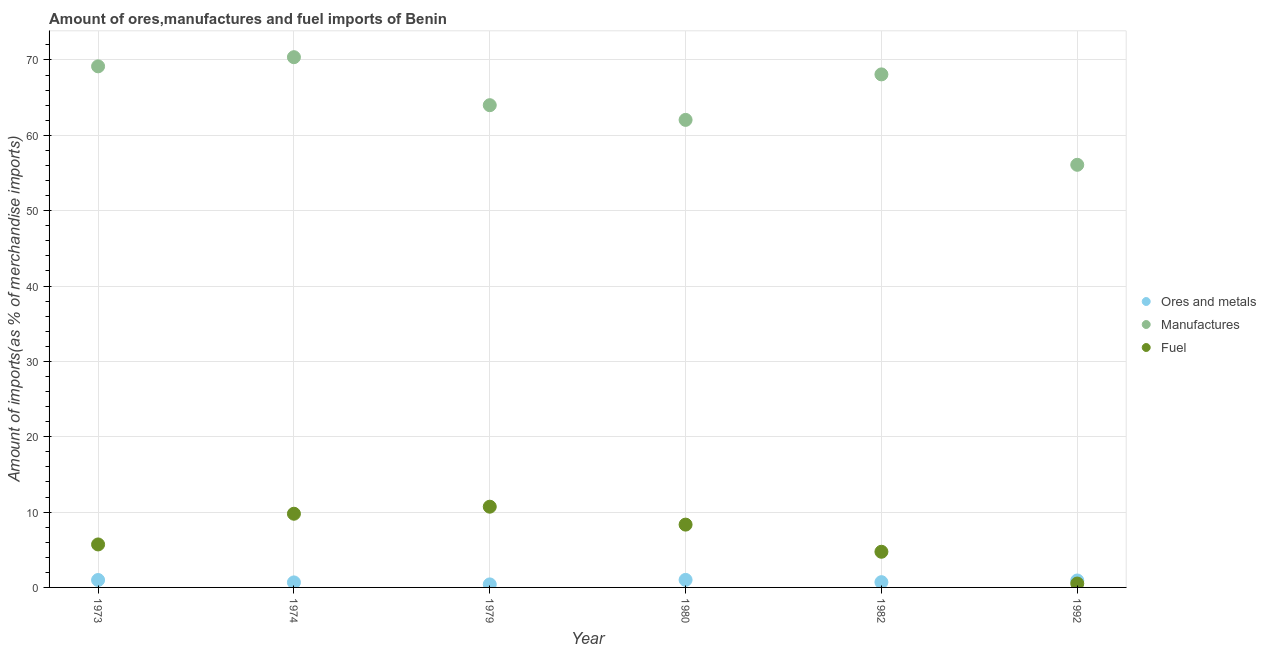What is the percentage of fuel imports in 1982?
Make the answer very short. 4.73. Across all years, what is the maximum percentage of fuel imports?
Ensure brevity in your answer.  10.71. Across all years, what is the minimum percentage of manufactures imports?
Your answer should be very brief. 56.08. In which year was the percentage of manufactures imports minimum?
Your answer should be very brief. 1992. What is the total percentage of ores and metals imports in the graph?
Your answer should be very brief. 4.67. What is the difference between the percentage of ores and metals imports in 1982 and that in 1992?
Keep it short and to the point. -0.22. What is the difference between the percentage of fuel imports in 1973 and the percentage of ores and metals imports in 1992?
Your answer should be compact. 4.78. What is the average percentage of manufactures imports per year?
Your answer should be compact. 64.95. In the year 1992, what is the difference between the percentage of fuel imports and percentage of ores and metals imports?
Give a very brief answer. -0.41. In how many years, is the percentage of fuel imports greater than 18 %?
Ensure brevity in your answer.  0. What is the ratio of the percentage of manufactures imports in 1974 to that in 1979?
Offer a terse response. 1.1. Is the difference between the percentage of ores and metals imports in 1974 and 1982 greater than the difference between the percentage of manufactures imports in 1974 and 1982?
Your answer should be compact. No. What is the difference between the highest and the second highest percentage of ores and metals imports?
Provide a succinct answer. 0.02. What is the difference between the highest and the lowest percentage of fuel imports?
Provide a short and direct response. 10.2. Does the percentage of fuel imports monotonically increase over the years?
Keep it short and to the point. No. Is the percentage of fuel imports strictly less than the percentage of ores and metals imports over the years?
Keep it short and to the point. No. How many dotlines are there?
Your answer should be compact. 3. What is the difference between two consecutive major ticks on the Y-axis?
Give a very brief answer. 10. Are the values on the major ticks of Y-axis written in scientific E-notation?
Your answer should be compact. No. Does the graph contain any zero values?
Provide a succinct answer. No. Does the graph contain grids?
Make the answer very short. Yes. How are the legend labels stacked?
Your response must be concise. Vertical. What is the title of the graph?
Make the answer very short. Amount of ores,manufactures and fuel imports of Benin. Does "Manufactures" appear as one of the legend labels in the graph?
Give a very brief answer. Yes. What is the label or title of the Y-axis?
Your answer should be very brief. Amount of imports(as % of merchandise imports). What is the Amount of imports(as % of merchandise imports) of Ores and metals in 1973?
Your answer should be compact. 0.98. What is the Amount of imports(as % of merchandise imports) of Manufactures in 1973?
Ensure brevity in your answer.  69.15. What is the Amount of imports(as % of merchandise imports) of Fuel in 1973?
Give a very brief answer. 5.7. What is the Amount of imports(as % of merchandise imports) in Ores and metals in 1974?
Ensure brevity in your answer.  0.67. What is the Amount of imports(as % of merchandise imports) of Manufactures in 1974?
Your response must be concise. 70.37. What is the Amount of imports(as % of merchandise imports) in Fuel in 1974?
Keep it short and to the point. 9.78. What is the Amount of imports(as % of merchandise imports) in Ores and metals in 1979?
Your answer should be very brief. 0.4. What is the Amount of imports(as % of merchandise imports) of Manufactures in 1979?
Your answer should be compact. 64. What is the Amount of imports(as % of merchandise imports) in Fuel in 1979?
Keep it short and to the point. 10.71. What is the Amount of imports(as % of merchandise imports) of Ores and metals in 1980?
Give a very brief answer. 1. What is the Amount of imports(as % of merchandise imports) in Manufactures in 1980?
Ensure brevity in your answer.  62.05. What is the Amount of imports(as % of merchandise imports) of Fuel in 1980?
Provide a short and direct response. 8.34. What is the Amount of imports(as % of merchandise imports) of Ores and metals in 1982?
Offer a terse response. 0.7. What is the Amount of imports(as % of merchandise imports) of Manufactures in 1982?
Make the answer very short. 68.08. What is the Amount of imports(as % of merchandise imports) of Fuel in 1982?
Your response must be concise. 4.73. What is the Amount of imports(as % of merchandise imports) of Ores and metals in 1992?
Ensure brevity in your answer.  0.92. What is the Amount of imports(as % of merchandise imports) in Manufactures in 1992?
Your answer should be compact. 56.08. What is the Amount of imports(as % of merchandise imports) of Fuel in 1992?
Give a very brief answer. 0.52. Across all years, what is the maximum Amount of imports(as % of merchandise imports) of Ores and metals?
Make the answer very short. 1. Across all years, what is the maximum Amount of imports(as % of merchandise imports) in Manufactures?
Keep it short and to the point. 70.37. Across all years, what is the maximum Amount of imports(as % of merchandise imports) in Fuel?
Ensure brevity in your answer.  10.71. Across all years, what is the minimum Amount of imports(as % of merchandise imports) of Ores and metals?
Your answer should be very brief. 0.4. Across all years, what is the minimum Amount of imports(as % of merchandise imports) in Manufactures?
Ensure brevity in your answer.  56.08. Across all years, what is the minimum Amount of imports(as % of merchandise imports) of Fuel?
Offer a terse response. 0.52. What is the total Amount of imports(as % of merchandise imports) in Ores and metals in the graph?
Keep it short and to the point. 4.67. What is the total Amount of imports(as % of merchandise imports) of Manufactures in the graph?
Provide a succinct answer. 389.73. What is the total Amount of imports(as % of merchandise imports) of Fuel in the graph?
Your response must be concise. 39.78. What is the difference between the Amount of imports(as % of merchandise imports) in Ores and metals in 1973 and that in 1974?
Your answer should be compact. 0.32. What is the difference between the Amount of imports(as % of merchandise imports) of Manufactures in 1973 and that in 1974?
Offer a terse response. -1.21. What is the difference between the Amount of imports(as % of merchandise imports) of Fuel in 1973 and that in 1974?
Offer a terse response. -4.07. What is the difference between the Amount of imports(as % of merchandise imports) of Ores and metals in 1973 and that in 1979?
Ensure brevity in your answer.  0.58. What is the difference between the Amount of imports(as % of merchandise imports) of Manufactures in 1973 and that in 1979?
Ensure brevity in your answer.  5.16. What is the difference between the Amount of imports(as % of merchandise imports) in Fuel in 1973 and that in 1979?
Ensure brevity in your answer.  -5.01. What is the difference between the Amount of imports(as % of merchandise imports) of Ores and metals in 1973 and that in 1980?
Your answer should be very brief. -0.02. What is the difference between the Amount of imports(as % of merchandise imports) in Manufactures in 1973 and that in 1980?
Your answer should be compact. 7.11. What is the difference between the Amount of imports(as % of merchandise imports) in Fuel in 1973 and that in 1980?
Keep it short and to the point. -2.63. What is the difference between the Amount of imports(as % of merchandise imports) in Ores and metals in 1973 and that in 1982?
Ensure brevity in your answer.  0.28. What is the difference between the Amount of imports(as % of merchandise imports) in Manufactures in 1973 and that in 1982?
Your response must be concise. 1.07. What is the difference between the Amount of imports(as % of merchandise imports) of Fuel in 1973 and that in 1982?
Provide a succinct answer. 0.97. What is the difference between the Amount of imports(as % of merchandise imports) in Ores and metals in 1973 and that in 1992?
Keep it short and to the point. 0.06. What is the difference between the Amount of imports(as % of merchandise imports) of Manufactures in 1973 and that in 1992?
Make the answer very short. 13.07. What is the difference between the Amount of imports(as % of merchandise imports) in Fuel in 1973 and that in 1992?
Provide a short and direct response. 5.19. What is the difference between the Amount of imports(as % of merchandise imports) of Ores and metals in 1974 and that in 1979?
Your answer should be very brief. 0.27. What is the difference between the Amount of imports(as % of merchandise imports) in Manufactures in 1974 and that in 1979?
Offer a very short reply. 6.37. What is the difference between the Amount of imports(as % of merchandise imports) in Fuel in 1974 and that in 1979?
Offer a terse response. -0.93. What is the difference between the Amount of imports(as % of merchandise imports) of Ores and metals in 1974 and that in 1980?
Offer a terse response. -0.33. What is the difference between the Amount of imports(as % of merchandise imports) in Manufactures in 1974 and that in 1980?
Offer a terse response. 8.32. What is the difference between the Amount of imports(as % of merchandise imports) of Fuel in 1974 and that in 1980?
Keep it short and to the point. 1.44. What is the difference between the Amount of imports(as % of merchandise imports) in Ores and metals in 1974 and that in 1982?
Provide a short and direct response. -0.03. What is the difference between the Amount of imports(as % of merchandise imports) in Manufactures in 1974 and that in 1982?
Provide a short and direct response. 2.28. What is the difference between the Amount of imports(as % of merchandise imports) in Fuel in 1974 and that in 1982?
Make the answer very short. 5.05. What is the difference between the Amount of imports(as % of merchandise imports) in Ores and metals in 1974 and that in 1992?
Your answer should be very brief. -0.25. What is the difference between the Amount of imports(as % of merchandise imports) in Manufactures in 1974 and that in 1992?
Provide a succinct answer. 14.28. What is the difference between the Amount of imports(as % of merchandise imports) in Fuel in 1974 and that in 1992?
Ensure brevity in your answer.  9.26. What is the difference between the Amount of imports(as % of merchandise imports) in Ores and metals in 1979 and that in 1980?
Offer a terse response. -0.6. What is the difference between the Amount of imports(as % of merchandise imports) of Manufactures in 1979 and that in 1980?
Provide a short and direct response. 1.95. What is the difference between the Amount of imports(as % of merchandise imports) in Fuel in 1979 and that in 1980?
Your answer should be very brief. 2.38. What is the difference between the Amount of imports(as % of merchandise imports) of Ores and metals in 1979 and that in 1982?
Provide a succinct answer. -0.3. What is the difference between the Amount of imports(as % of merchandise imports) of Manufactures in 1979 and that in 1982?
Provide a succinct answer. -4.09. What is the difference between the Amount of imports(as % of merchandise imports) of Fuel in 1979 and that in 1982?
Ensure brevity in your answer.  5.98. What is the difference between the Amount of imports(as % of merchandise imports) in Ores and metals in 1979 and that in 1992?
Keep it short and to the point. -0.52. What is the difference between the Amount of imports(as % of merchandise imports) of Manufactures in 1979 and that in 1992?
Offer a very short reply. 7.91. What is the difference between the Amount of imports(as % of merchandise imports) in Fuel in 1979 and that in 1992?
Your answer should be very brief. 10.2. What is the difference between the Amount of imports(as % of merchandise imports) of Ores and metals in 1980 and that in 1982?
Your answer should be very brief. 0.3. What is the difference between the Amount of imports(as % of merchandise imports) of Manufactures in 1980 and that in 1982?
Provide a succinct answer. -6.04. What is the difference between the Amount of imports(as % of merchandise imports) in Fuel in 1980 and that in 1982?
Keep it short and to the point. 3.6. What is the difference between the Amount of imports(as % of merchandise imports) of Ores and metals in 1980 and that in 1992?
Keep it short and to the point. 0.08. What is the difference between the Amount of imports(as % of merchandise imports) of Manufactures in 1980 and that in 1992?
Provide a succinct answer. 5.96. What is the difference between the Amount of imports(as % of merchandise imports) in Fuel in 1980 and that in 1992?
Ensure brevity in your answer.  7.82. What is the difference between the Amount of imports(as % of merchandise imports) in Ores and metals in 1982 and that in 1992?
Offer a very short reply. -0.22. What is the difference between the Amount of imports(as % of merchandise imports) of Manufactures in 1982 and that in 1992?
Offer a terse response. 12. What is the difference between the Amount of imports(as % of merchandise imports) in Fuel in 1982 and that in 1992?
Provide a succinct answer. 4.22. What is the difference between the Amount of imports(as % of merchandise imports) of Ores and metals in 1973 and the Amount of imports(as % of merchandise imports) of Manufactures in 1974?
Make the answer very short. -69.38. What is the difference between the Amount of imports(as % of merchandise imports) in Ores and metals in 1973 and the Amount of imports(as % of merchandise imports) in Fuel in 1974?
Keep it short and to the point. -8.8. What is the difference between the Amount of imports(as % of merchandise imports) of Manufactures in 1973 and the Amount of imports(as % of merchandise imports) of Fuel in 1974?
Provide a short and direct response. 59.37. What is the difference between the Amount of imports(as % of merchandise imports) in Ores and metals in 1973 and the Amount of imports(as % of merchandise imports) in Manufactures in 1979?
Provide a short and direct response. -63.01. What is the difference between the Amount of imports(as % of merchandise imports) of Ores and metals in 1973 and the Amount of imports(as % of merchandise imports) of Fuel in 1979?
Provide a short and direct response. -9.73. What is the difference between the Amount of imports(as % of merchandise imports) of Manufactures in 1973 and the Amount of imports(as % of merchandise imports) of Fuel in 1979?
Offer a very short reply. 58.44. What is the difference between the Amount of imports(as % of merchandise imports) in Ores and metals in 1973 and the Amount of imports(as % of merchandise imports) in Manufactures in 1980?
Provide a short and direct response. -61.06. What is the difference between the Amount of imports(as % of merchandise imports) in Ores and metals in 1973 and the Amount of imports(as % of merchandise imports) in Fuel in 1980?
Your answer should be compact. -7.35. What is the difference between the Amount of imports(as % of merchandise imports) in Manufactures in 1973 and the Amount of imports(as % of merchandise imports) in Fuel in 1980?
Provide a short and direct response. 60.82. What is the difference between the Amount of imports(as % of merchandise imports) of Ores and metals in 1973 and the Amount of imports(as % of merchandise imports) of Manufactures in 1982?
Make the answer very short. -67.1. What is the difference between the Amount of imports(as % of merchandise imports) in Ores and metals in 1973 and the Amount of imports(as % of merchandise imports) in Fuel in 1982?
Offer a very short reply. -3.75. What is the difference between the Amount of imports(as % of merchandise imports) of Manufactures in 1973 and the Amount of imports(as % of merchandise imports) of Fuel in 1982?
Ensure brevity in your answer.  64.42. What is the difference between the Amount of imports(as % of merchandise imports) of Ores and metals in 1973 and the Amount of imports(as % of merchandise imports) of Manufactures in 1992?
Provide a succinct answer. -55.1. What is the difference between the Amount of imports(as % of merchandise imports) in Ores and metals in 1973 and the Amount of imports(as % of merchandise imports) in Fuel in 1992?
Provide a succinct answer. 0.47. What is the difference between the Amount of imports(as % of merchandise imports) in Manufactures in 1973 and the Amount of imports(as % of merchandise imports) in Fuel in 1992?
Your answer should be very brief. 68.64. What is the difference between the Amount of imports(as % of merchandise imports) of Ores and metals in 1974 and the Amount of imports(as % of merchandise imports) of Manufactures in 1979?
Your response must be concise. -63.33. What is the difference between the Amount of imports(as % of merchandise imports) of Ores and metals in 1974 and the Amount of imports(as % of merchandise imports) of Fuel in 1979?
Provide a short and direct response. -10.05. What is the difference between the Amount of imports(as % of merchandise imports) of Manufactures in 1974 and the Amount of imports(as % of merchandise imports) of Fuel in 1979?
Keep it short and to the point. 59.65. What is the difference between the Amount of imports(as % of merchandise imports) in Ores and metals in 1974 and the Amount of imports(as % of merchandise imports) in Manufactures in 1980?
Your response must be concise. -61.38. What is the difference between the Amount of imports(as % of merchandise imports) in Ores and metals in 1974 and the Amount of imports(as % of merchandise imports) in Fuel in 1980?
Offer a very short reply. -7.67. What is the difference between the Amount of imports(as % of merchandise imports) in Manufactures in 1974 and the Amount of imports(as % of merchandise imports) in Fuel in 1980?
Give a very brief answer. 62.03. What is the difference between the Amount of imports(as % of merchandise imports) of Ores and metals in 1974 and the Amount of imports(as % of merchandise imports) of Manufactures in 1982?
Your response must be concise. -67.42. What is the difference between the Amount of imports(as % of merchandise imports) of Ores and metals in 1974 and the Amount of imports(as % of merchandise imports) of Fuel in 1982?
Provide a short and direct response. -4.07. What is the difference between the Amount of imports(as % of merchandise imports) in Manufactures in 1974 and the Amount of imports(as % of merchandise imports) in Fuel in 1982?
Your answer should be very brief. 65.63. What is the difference between the Amount of imports(as % of merchandise imports) of Ores and metals in 1974 and the Amount of imports(as % of merchandise imports) of Manufactures in 1992?
Provide a short and direct response. -55.42. What is the difference between the Amount of imports(as % of merchandise imports) in Ores and metals in 1974 and the Amount of imports(as % of merchandise imports) in Fuel in 1992?
Your response must be concise. 0.15. What is the difference between the Amount of imports(as % of merchandise imports) in Manufactures in 1974 and the Amount of imports(as % of merchandise imports) in Fuel in 1992?
Offer a terse response. 69.85. What is the difference between the Amount of imports(as % of merchandise imports) of Ores and metals in 1979 and the Amount of imports(as % of merchandise imports) of Manufactures in 1980?
Give a very brief answer. -61.65. What is the difference between the Amount of imports(as % of merchandise imports) in Ores and metals in 1979 and the Amount of imports(as % of merchandise imports) in Fuel in 1980?
Your response must be concise. -7.94. What is the difference between the Amount of imports(as % of merchandise imports) of Manufactures in 1979 and the Amount of imports(as % of merchandise imports) of Fuel in 1980?
Your answer should be compact. 55.66. What is the difference between the Amount of imports(as % of merchandise imports) in Ores and metals in 1979 and the Amount of imports(as % of merchandise imports) in Manufactures in 1982?
Make the answer very short. -67.68. What is the difference between the Amount of imports(as % of merchandise imports) of Ores and metals in 1979 and the Amount of imports(as % of merchandise imports) of Fuel in 1982?
Offer a very short reply. -4.33. What is the difference between the Amount of imports(as % of merchandise imports) in Manufactures in 1979 and the Amount of imports(as % of merchandise imports) in Fuel in 1982?
Give a very brief answer. 59.26. What is the difference between the Amount of imports(as % of merchandise imports) of Ores and metals in 1979 and the Amount of imports(as % of merchandise imports) of Manufactures in 1992?
Keep it short and to the point. -55.68. What is the difference between the Amount of imports(as % of merchandise imports) of Ores and metals in 1979 and the Amount of imports(as % of merchandise imports) of Fuel in 1992?
Your answer should be compact. -0.11. What is the difference between the Amount of imports(as % of merchandise imports) in Manufactures in 1979 and the Amount of imports(as % of merchandise imports) in Fuel in 1992?
Make the answer very short. 63.48. What is the difference between the Amount of imports(as % of merchandise imports) in Ores and metals in 1980 and the Amount of imports(as % of merchandise imports) in Manufactures in 1982?
Your response must be concise. -67.08. What is the difference between the Amount of imports(as % of merchandise imports) in Ores and metals in 1980 and the Amount of imports(as % of merchandise imports) in Fuel in 1982?
Ensure brevity in your answer.  -3.73. What is the difference between the Amount of imports(as % of merchandise imports) of Manufactures in 1980 and the Amount of imports(as % of merchandise imports) of Fuel in 1982?
Ensure brevity in your answer.  57.31. What is the difference between the Amount of imports(as % of merchandise imports) of Ores and metals in 1980 and the Amount of imports(as % of merchandise imports) of Manufactures in 1992?
Offer a terse response. -55.09. What is the difference between the Amount of imports(as % of merchandise imports) of Ores and metals in 1980 and the Amount of imports(as % of merchandise imports) of Fuel in 1992?
Your answer should be compact. 0.48. What is the difference between the Amount of imports(as % of merchandise imports) of Manufactures in 1980 and the Amount of imports(as % of merchandise imports) of Fuel in 1992?
Your answer should be very brief. 61.53. What is the difference between the Amount of imports(as % of merchandise imports) of Ores and metals in 1982 and the Amount of imports(as % of merchandise imports) of Manufactures in 1992?
Make the answer very short. -55.39. What is the difference between the Amount of imports(as % of merchandise imports) in Ores and metals in 1982 and the Amount of imports(as % of merchandise imports) in Fuel in 1992?
Keep it short and to the point. 0.18. What is the difference between the Amount of imports(as % of merchandise imports) of Manufactures in 1982 and the Amount of imports(as % of merchandise imports) of Fuel in 1992?
Offer a terse response. 67.57. What is the average Amount of imports(as % of merchandise imports) of Ores and metals per year?
Give a very brief answer. 0.78. What is the average Amount of imports(as % of merchandise imports) of Manufactures per year?
Keep it short and to the point. 64.95. What is the average Amount of imports(as % of merchandise imports) of Fuel per year?
Make the answer very short. 6.63. In the year 1973, what is the difference between the Amount of imports(as % of merchandise imports) in Ores and metals and Amount of imports(as % of merchandise imports) in Manufactures?
Give a very brief answer. -68.17. In the year 1973, what is the difference between the Amount of imports(as % of merchandise imports) in Ores and metals and Amount of imports(as % of merchandise imports) in Fuel?
Give a very brief answer. -4.72. In the year 1973, what is the difference between the Amount of imports(as % of merchandise imports) of Manufactures and Amount of imports(as % of merchandise imports) of Fuel?
Give a very brief answer. 63.45. In the year 1974, what is the difference between the Amount of imports(as % of merchandise imports) in Ores and metals and Amount of imports(as % of merchandise imports) in Manufactures?
Offer a very short reply. -69.7. In the year 1974, what is the difference between the Amount of imports(as % of merchandise imports) in Ores and metals and Amount of imports(as % of merchandise imports) in Fuel?
Keep it short and to the point. -9.11. In the year 1974, what is the difference between the Amount of imports(as % of merchandise imports) of Manufactures and Amount of imports(as % of merchandise imports) of Fuel?
Offer a very short reply. 60.59. In the year 1979, what is the difference between the Amount of imports(as % of merchandise imports) of Ores and metals and Amount of imports(as % of merchandise imports) of Manufactures?
Make the answer very short. -63.6. In the year 1979, what is the difference between the Amount of imports(as % of merchandise imports) in Ores and metals and Amount of imports(as % of merchandise imports) in Fuel?
Your answer should be very brief. -10.31. In the year 1979, what is the difference between the Amount of imports(as % of merchandise imports) in Manufactures and Amount of imports(as % of merchandise imports) in Fuel?
Offer a very short reply. 53.28. In the year 1980, what is the difference between the Amount of imports(as % of merchandise imports) in Ores and metals and Amount of imports(as % of merchandise imports) in Manufactures?
Offer a terse response. -61.05. In the year 1980, what is the difference between the Amount of imports(as % of merchandise imports) of Ores and metals and Amount of imports(as % of merchandise imports) of Fuel?
Keep it short and to the point. -7.34. In the year 1980, what is the difference between the Amount of imports(as % of merchandise imports) in Manufactures and Amount of imports(as % of merchandise imports) in Fuel?
Your answer should be compact. 53.71. In the year 1982, what is the difference between the Amount of imports(as % of merchandise imports) of Ores and metals and Amount of imports(as % of merchandise imports) of Manufactures?
Give a very brief answer. -67.39. In the year 1982, what is the difference between the Amount of imports(as % of merchandise imports) in Ores and metals and Amount of imports(as % of merchandise imports) in Fuel?
Keep it short and to the point. -4.03. In the year 1982, what is the difference between the Amount of imports(as % of merchandise imports) in Manufactures and Amount of imports(as % of merchandise imports) in Fuel?
Your answer should be compact. 63.35. In the year 1992, what is the difference between the Amount of imports(as % of merchandise imports) of Ores and metals and Amount of imports(as % of merchandise imports) of Manufactures?
Ensure brevity in your answer.  -55.16. In the year 1992, what is the difference between the Amount of imports(as % of merchandise imports) in Ores and metals and Amount of imports(as % of merchandise imports) in Fuel?
Your answer should be very brief. 0.41. In the year 1992, what is the difference between the Amount of imports(as % of merchandise imports) of Manufactures and Amount of imports(as % of merchandise imports) of Fuel?
Give a very brief answer. 55.57. What is the ratio of the Amount of imports(as % of merchandise imports) in Ores and metals in 1973 to that in 1974?
Provide a short and direct response. 1.47. What is the ratio of the Amount of imports(as % of merchandise imports) of Manufactures in 1973 to that in 1974?
Offer a very short reply. 0.98. What is the ratio of the Amount of imports(as % of merchandise imports) of Fuel in 1973 to that in 1974?
Provide a succinct answer. 0.58. What is the ratio of the Amount of imports(as % of merchandise imports) in Ores and metals in 1973 to that in 1979?
Your answer should be very brief. 2.45. What is the ratio of the Amount of imports(as % of merchandise imports) of Manufactures in 1973 to that in 1979?
Keep it short and to the point. 1.08. What is the ratio of the Amount of imports(as % of merchandise imports) in Fuel in 1973 to that in 1979?
Offer a terse response. 0.53. What is the ratio of the Amount of imports(as % of merchandise imports) in Ores and metals in 1973 to that in 1980?
Your response must be concise. 0.98. What is the ratio of the Amount of imports(as % of merchandise imports) in Manufactures in 1973 to that in 1980?
Give a very brief answer. 1.11. What is the ratio of the Amount of imports(as % of merchandise imports) of Fuel in 1973 to that in 1980?
Give a very brief answer. 0.68. What is the ratio of the Amount of imports(as % of merchandise imports) of Ores and metals in 1973 to that in 1982?
Make the answer very short. 1.41. What is the ratio of the Amount of imports(as % of merchandise imports) of Manufactures in 1973 to that in 1982?
Offer a terse response. 1.02. What is the ratio of the Amount of imports(as % of merchandise imports) in Fuel in 1973 to that in 1982?
Provide a succinct answer. 1.21. What is the ratio of the Amount of imports(as % of merchandise imports) of Ores and metals in 1973 to that in 1992?
Provide a succinct answer. 1.07. What is the ratio of the Amount of imports(as % of merchandise imports) of Manufactures in 1973 to that in 1992?
Keep it short and to the point. 1.23. What is the ratio of the Amount of imports(as % of merchandise imports) in Fuel in 1973 to that in 1992?
Your answer should be very brief. 11.07. What is the ratio of the Amount of imports(as % of merchandise imports) in Ores and metals in 1974 to that in 1979?
Give a very brief answer. 1.67. What is the ratio of the Amount of imports(as % of merchandise imports) of Manufactures in 1974 to that in 1979?
Your answer should be compact. 1.1. What is the ratio of the Amount of imports(as % of merchandise imports) of Fuel in 1974 to that in 1979?
Ensure brevity in your answer.  0.91. What is the ratio of the Amount of imports(as % of merchandise imports) in Ores and metals in 1974 to that in 1980?
Provide a succinct answer. 0.67. What is the ratio of the Amount of imports(as % of merchandise imports) in Manufactures in 1974 to that in 1980?
Make the answer very short. 1.13. What is the ratio of the Amount of imports(as % of merchandise imports) in Fuel in 1974 to that in 1980?
Ensure brevity in your answer.  1.17. What is the ratio of the Amount of imports(as % of merchandise imports) in Ores and metals in 1974 to that in 1982?
Give a very brief answer. 0.96. What is the ratio of the Amount of imports(as % of merchandise imports) in Manufactures in 1974 to that in 1982?
Your answer should be very brief. 1.03. What is the ratio of the Amount of imports(as % of merchandise imports) in Fuel in 1974 to that in 1982?
Keep it short and to the point. 2.07. What is the ratio of the Amount of imports(as % of merchandise imports) in Ores and metals in 1974 to that in 1992?
Make the answer very short. 0.72. What is the ratio of the Amount of imports(as % of merchandise imports) of Manufactures in 1974 to that in 1992?
Your answer should be compact. 1.25. What is the ratio of the Amount of imports(as % of merchandise imports) in Fuel in 1974 to that in 1992?
Provide a succinct answer. 18.97. What is the ratio of the Amount of imports(as % of merchandise imports) of Ores and metals in 1979 to that in 1980?
Ensure brevity in your answer.  0.4. What is the ratio of the Amount of imports(as % of merchandise imports) in Manufactures in 1979 to that in 1980?
Provide a succinct answer. 1.03. What is the ratio of the Amount of imports(as % of merchandise imports) in Fuel in 1979 to that in 1980?
Your response must be concise. 1.29. What is the ratio of the Amount of imports(as % of merchandise imports) of Ores and metals in 1979 to that in 1982?
Give a very brief answer. 0.57. What is the ratio of the Amount of imports(as % of merchandise imports) of Fuel in 1979 to that in 1982?
Give a very brief answer. 2.26. What is the ratio of the Amount of imports(as % of merchandise imports) of Ores and metals in 1979 to that in 1992?
Ensure brevity in your answer.  0.43. What is the ratio of the Amount of imports(as % of merchandise imports) of Manufactures in 1979 to that in 1992?
Your response must be concise. 1.14. What is the ratio of the Amount of imports(as % of merchandise imports) of Fuel in 1979 to that in 1992?
Ensure brevity in your answer.  20.78. What is the ratio of the Amount of imports(as % of merchandise imports) of Ores and metals in 1980 to that in 1982?
Offer a very short reply. 1.43. What is the ratio of the Amount of imports(as % of merchandise imports) of Manufactures in 1980 to that in 1982?
Ensure brevity in your answer.  0.91. What is the ratio of the Amount of imports(as % of merchandise imports) in Fuel in 1980 to that in 1982?
Offer a terse response. 1.76. What is the ratio of the Amount of imports(as % of merchandise imports) of Ores and metals in 1980 to that in 1992?
Provide a succinct answer. 1.08. What is the ratio of the Amount of imports(as % of merchandise imports) of Manufactures in 1980 to that in 1992?
Provide a short and direct response. 1.11. What is the ratio of the Amount of imports(as % of merchandise imports) of Fuel in 1980 to that in 1992?
Your answer should be compact. 16.17. What is the ratio of the Amount of imports(as % of merchandise imports) of Ores and metals in 1982 to that in 1992?
Give a very brief answer. 0.76. What is the ratio of the Amount of imports(as % of merchandise imports) in Manufactures in 1982 to that in 1992?
Ensure brevity in your answer.  1.21. What is the ratio of the Amount of imports(as % of merchandise imports) of Fuel in 1982 to that in 1992?
Your response must be concise. 9.18. What is the difference between the highest and the second highest Amount of imports(as % of merchandise imports) in Ores and metals?
Your answer should be very brief. 0.02. What is the difference between the highest and the second highest Amount of imports(as % of merchandise imports) in Manufactures?
Give a very brief answer. 1.21. What is the difference between the highest and the second highest Amount of imports(as % of merchandise imports) in Fuel?
Your answer should be compact. 0.93. What is the difference between the highest and the lowest Amount of imports(as % of merchandise imports) in Ores and metals?
Your answer should be very brief. 0.6. What is the difference between the highest and the lowest Amount of imports(as % of merchandise imports) of Manufactures?
Provide a short and direct response. 14.28. What is the difference between the highest and the lowest Amount of imports(as % of merchandise imports) in Fuel?
Your response must be concise. 10.2. 